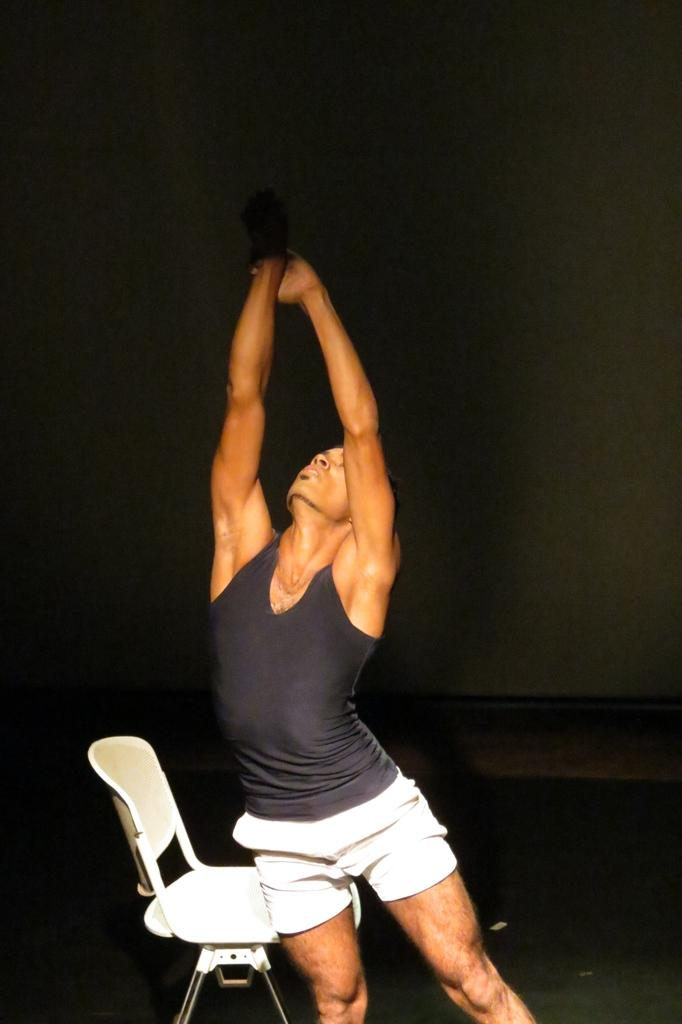Who or what is present in the image? There is a person in the image. What is the person sitting on in the image? There is a chair in the image. What can be seen beneath the person and chair? The ground is visible in the image. What is visible behind the person and chair? There is a wall in the background of the image. What type of nut is being used to test the yak in the image? There is no nut or yak present in the image; it only features a person, a chair, the ground, and a wall in the background. 